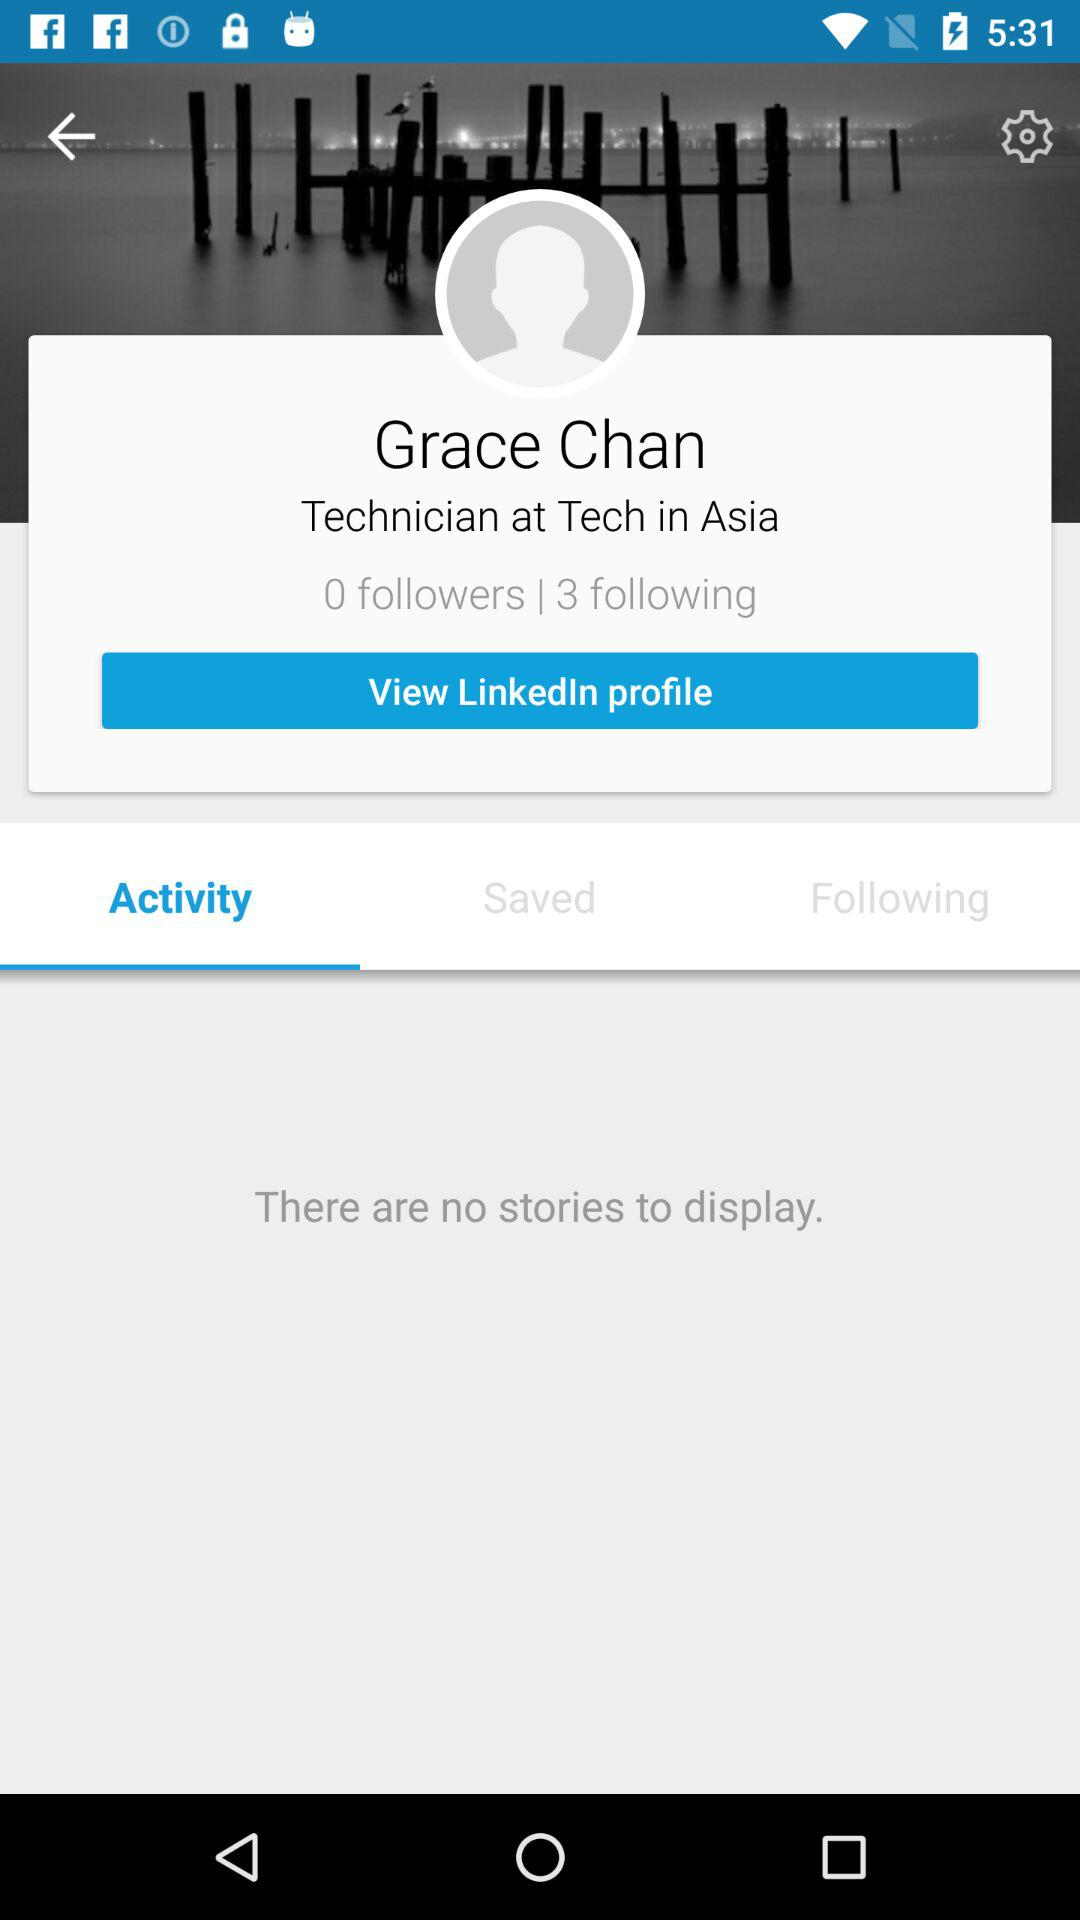How many followers does Grace Chan have?
Answer the question using a single word or phrase. 0 